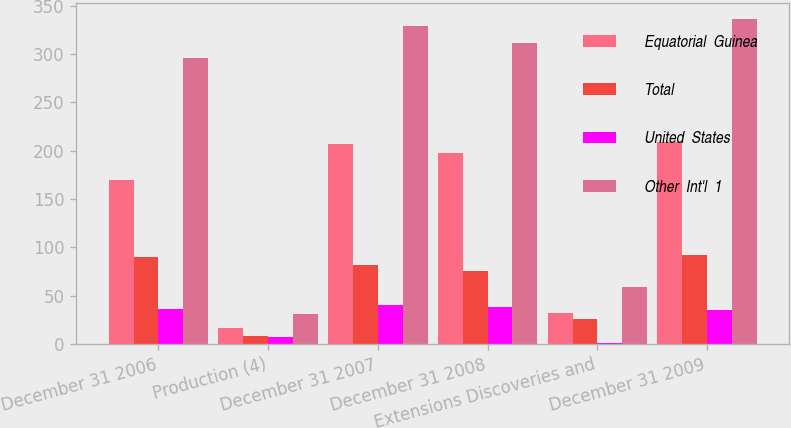Convert chart. <chart><loc_0><loc_0><loc_500><loc_500><stacked_bar_chart><ecel><fcel>December 31 2006<fcel>Production (4)<fcel>December 31 2007<fcel>December 31 2008<fcel>Extensions Discoveries and<fcel>December 31 2009<nl><fcel>Equatorial  Guinea<fcel>170<fcel>16<fcel>207<fcel>198<fcel>32<fcel>209<nl><fcel>Total<fcel>90<fcel>8<fcel>82<fcel>75<fcel>26<fcel>92<nl><fcel>United  States<fcel>36<fcel>7<fcel>40<fcel>38<fcel>1<fcel>35<nl><fcel>Other  Int'l  1<fcel>296<fcel>31<fcel>329<fcel>311<fcel>59<fcel>336<nl></chart> 